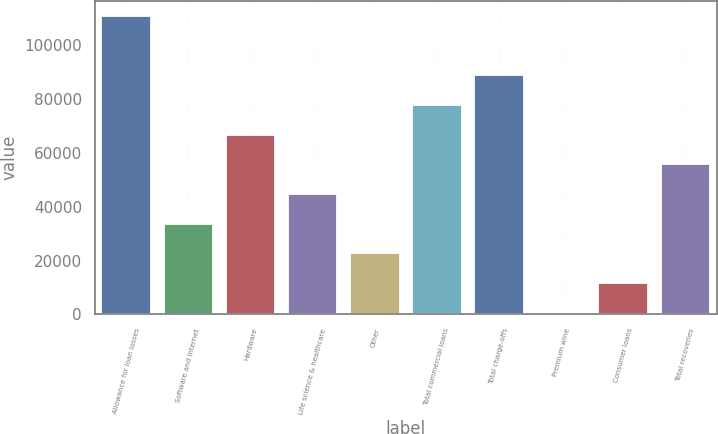<chart> <loc_0><loc_0><loc_500><loc_500><bar_chart><fcel>Allowance for loan losses<fcel>Software and internet<fcel>Hardware<fcel>Life science & healthcare<fcel>Other<fcel>Total commercial loans<fcel>Total charge-offs<fcel>Premium wine<fcel>Consumer loans<fcel>Total recoveries<nl><fcel>110651<fcel>33650.3<fcel>66650.6<fcel>44650.4<fcel>22650.2<fcel>77650.7<fcel>88650.8<fcel>650<fcel>11650.1<fcel>55650.5<nl></chart> 